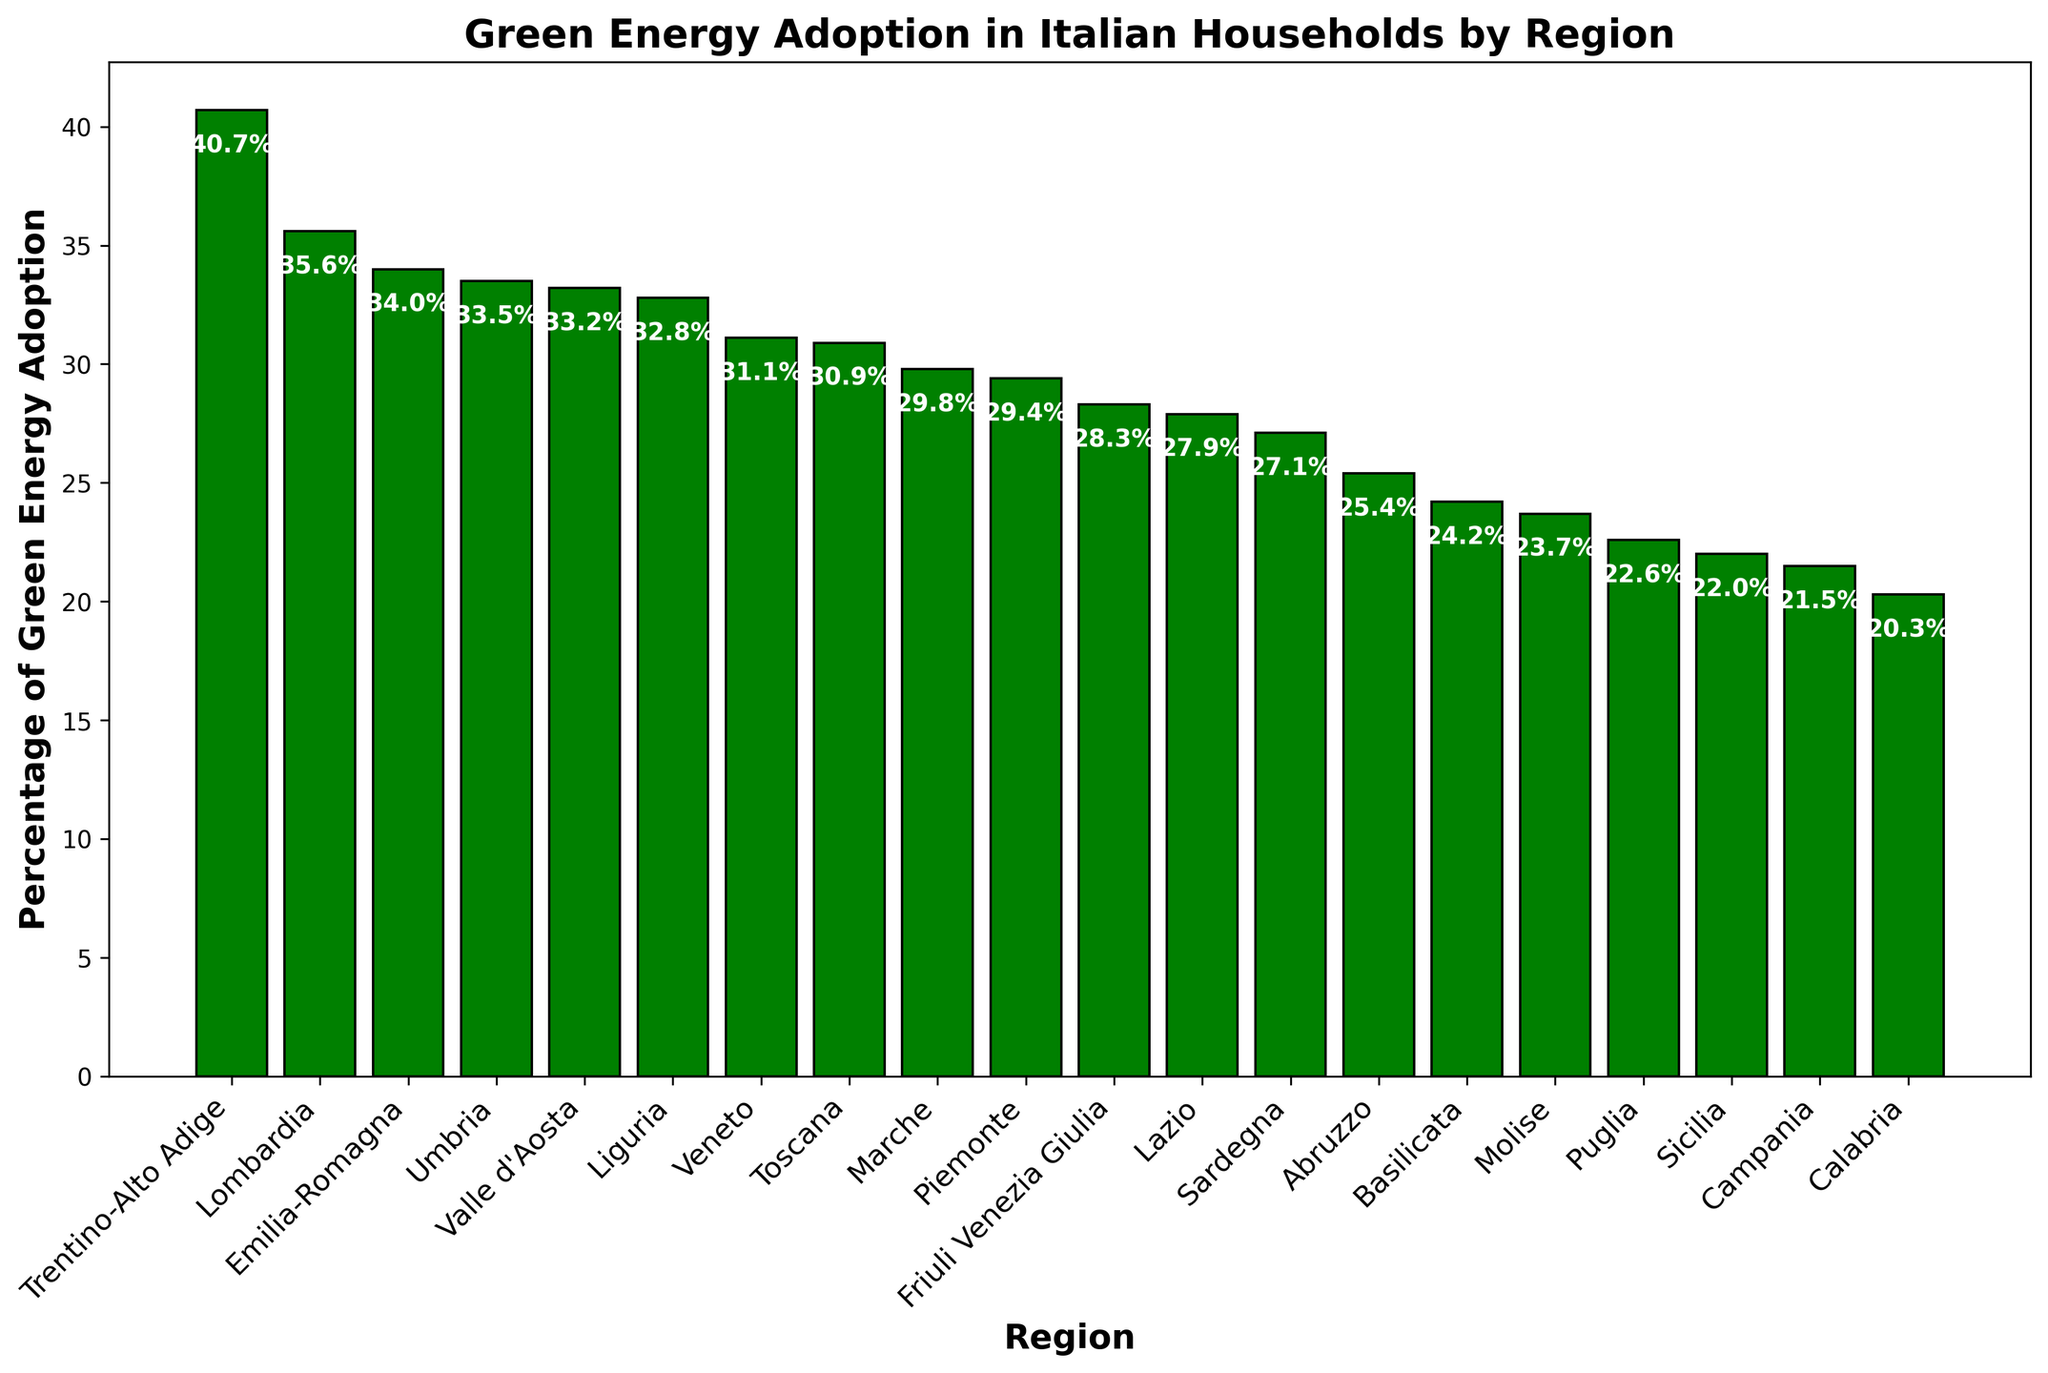Which region has the highest percentage of green energy adoption? The highest bar in the chart represents the region with the highest percentage of green energy adoption.
Answer: Trentino-Alto Adige Which region has the lowest percentage of green energy adoption? The lowest bar in the chart represents the region with the lowest percentage of green energy adoption.
Answer: Calabria How much higher is the percentage of green energy adoption in Lombardia compared to Lazio? Look at the heights of the bars for Lombardia and Lazio and subtract the percentage of Lazio from Lombardia. Lombardia has 35.6% and Lazio has 27.9%, so 35.6% - 27.9% = 7.7%.
Answer: 7.7% List all the regions with a percentage of green energy adoption greater than 30%. Identify all bars higher than the 30% mark. Those regions are Valle d'Aosta (33.2%), Piemonte (29.4%), Lombardia (35.6%), Trentino-Alto Adige (40.7%), Veneto (31.1%), Liguria (32.8%), Emilia-Romagna (34.0%), and Umbria (33.5%).
Answer: Valle d'Aosta, Lombardia, Trentino-Alto Adige, Veneto, Liguria, Emilia-Romagna, Umbria What is the average percentage of green energy adoption across all regions? Sum the percentages of all regions and divide by the number of regions. (33.2 + 29.4 + 35.6 + 40.7 + 31.1 + 28.3 + 32.8 + 34.0 + 30.9 + 33.5 + 29.8 + 27.9 + 25.4 + 23.7 + 21.5 + 22.6 + 24.2 + 20.3 + 22.0 + 27.1) / 20 = 29.2%.
Answer: 29.2% How many regions have a green energy adoption percentage below the national average? First, calculate the national average (29.2%). Then count the number of bars with a height (percentage) below this value. Ten regions have percentages below 29.2%.
Answer: 10 Is the percentage difference between the highest and the lowest adopting region greater than 20%? Calculate the difference between Trentino-Alto Adige (40.7%) and Calabria (20.3%). The difference is 40.7% - 20.3% = 20.4%, which is greater than 20%.
Answer: Yes What is the median percentage of green energy adoption across all regions? Order the percentages and find the middle value. With 20 regions, the median is the average of the 10th and 11th values. Ordered values: (20.3, 21.5, 22.0, 22.6, 23.7, 24.2, 25.4, 27.1, 27.9, 28.3, 29.4, 29.8, 30.9, 31.1, 32.8, 33.2, 33.5, 34.0, 35.6, 40.7). Median = (28.3 + 29.4) / 2 = 28.85%.
Answer: 28.85% Which region has the most similar green energy adoption rate to Emilia-Romagna? Identify the bar with a height closest to Emilia-Romagna’s 34.0%. Liguria with 32.8% is the closest.
Answer: Liguria How does the green energy adoption in Veneto compare to that in Friuli Venezia Giulia? Compare the heights of the bars for Veneto and Friuli Venezia Giulia. Veneto’s bar is 31.1% and Friuli Venezia Giulia's is 28.3%, hence Veneto has a higher percentage by 2.8%.
Answer: Veneto is higher by 2.8% 